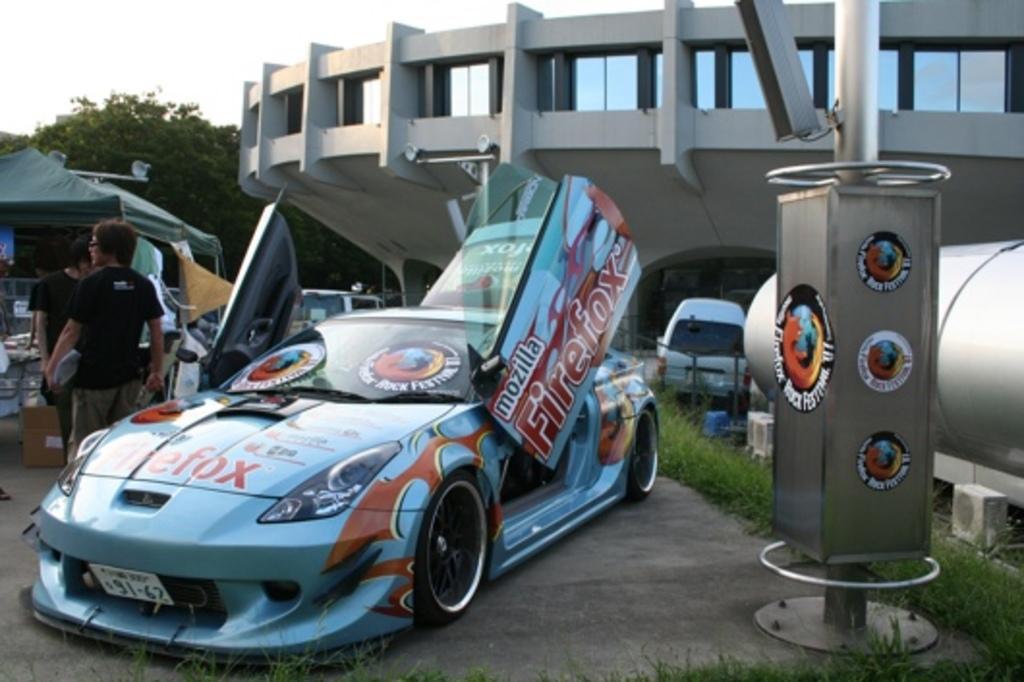Can you describe this image briefly? In the center of the image we can see a few vehicles. And we can see some text on the front vehicle. On the right side of the image, we can see one cylinder type object, one pole, grass and banners. On the banners, we can see some text. In the background, we can see the sky, clouds, trees, one building, one tent, banners, few people are standing and a few other objects. 